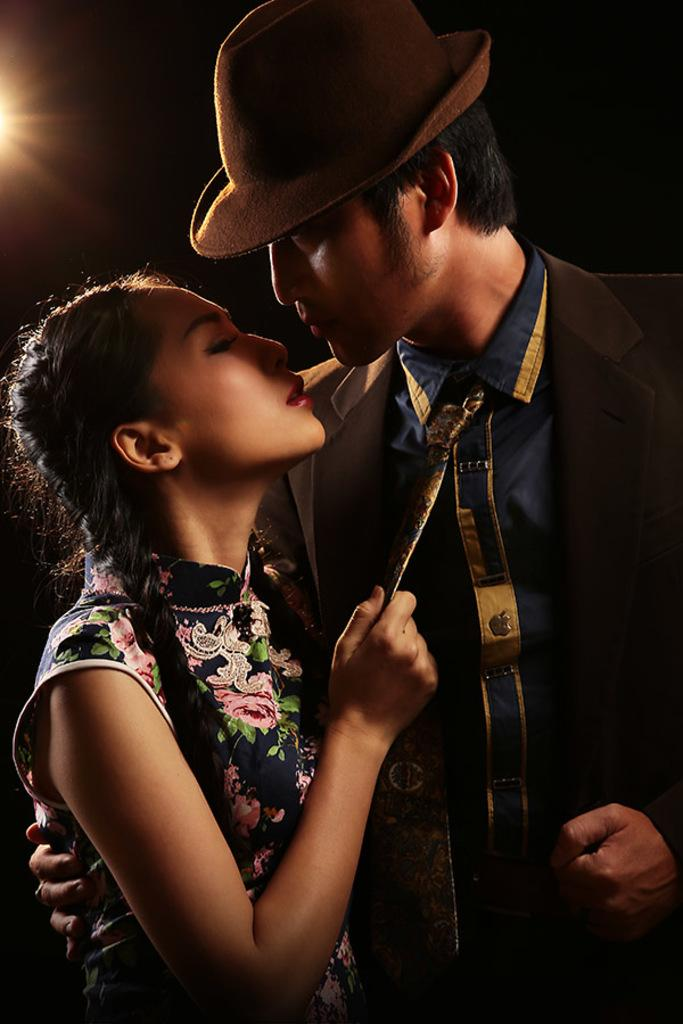How many people are in the image? There are persons in the image. What are the persons wearing? The persons are wearing clothes. Can you describe the person on the right side of the image? The person on the right side of the image is wearing a hat. What letter is the person on the right side of the image holding? There is no letter present in the image; the person on the right side of the image is wearing a hat. What type of drink is the person on the left side of the image holding? There is no drink present in the image; the persons are wearing clothes. 